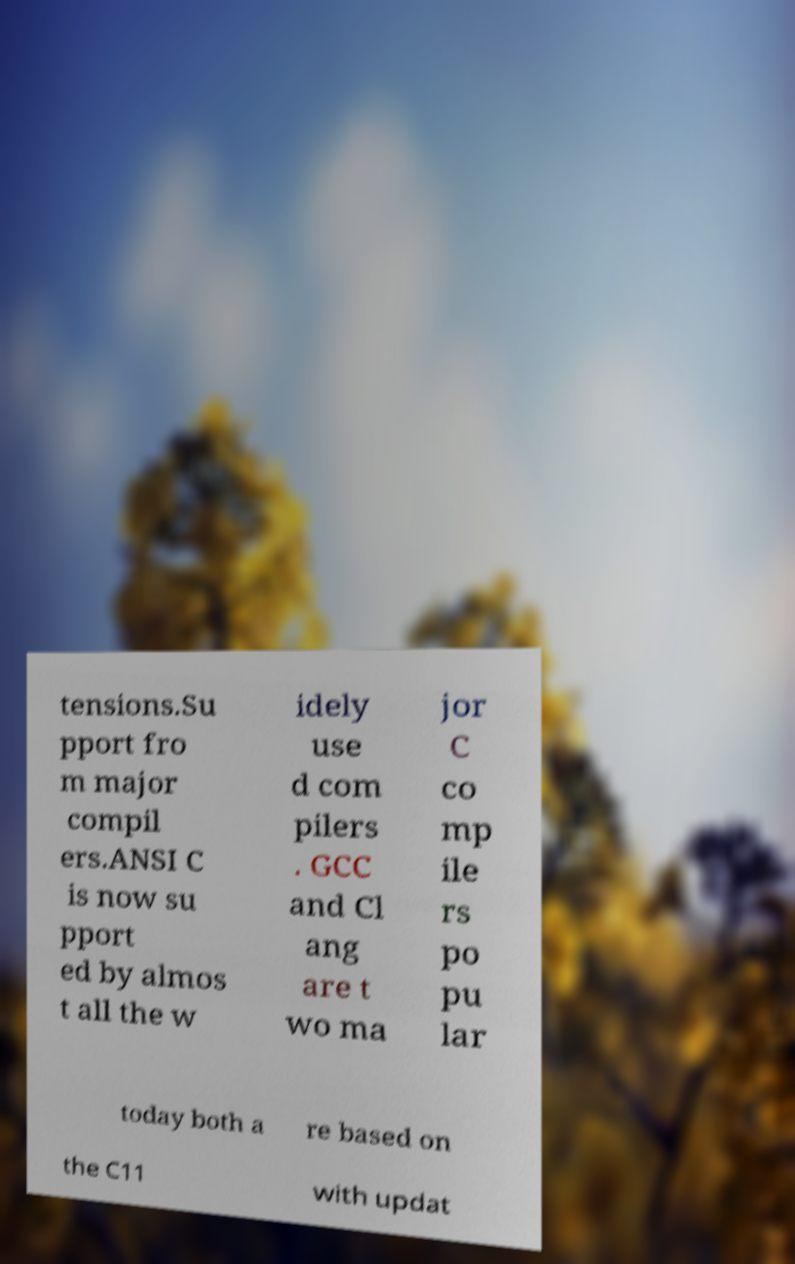Could you assist in decoding the text presented in this image and type it out clearly? tensions.Su pport fro m major compil ers.ANSI C is now su pport ed by almos t all the w idely use d com pilers . GCC and Cl ang are t wo ma jor C co mp ile rs po pu lar today both a re based on the C11 with updat 